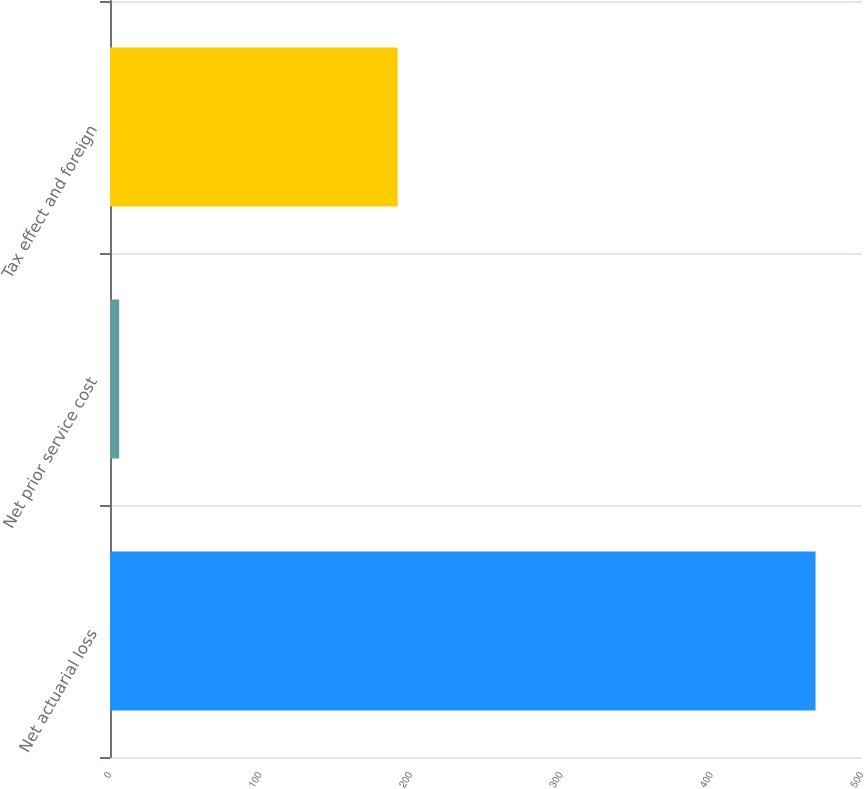<chart> <loc_0><loc_0><loc_500><loc_500><bar_chart><fcel>Net actuarial loss<fcel>Net prior service cost<fcel>Tax effect and foreign<nl><fcel>469.1<fcel>6.1<fcel>191.2<nl></chart> 